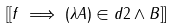Convert formula to latex. <formula><loc_0><loc_0><loc_500><loc_500>[ [ f \implies ( \lambda A ) \in d { 2 } \land B ] ]</formula> 